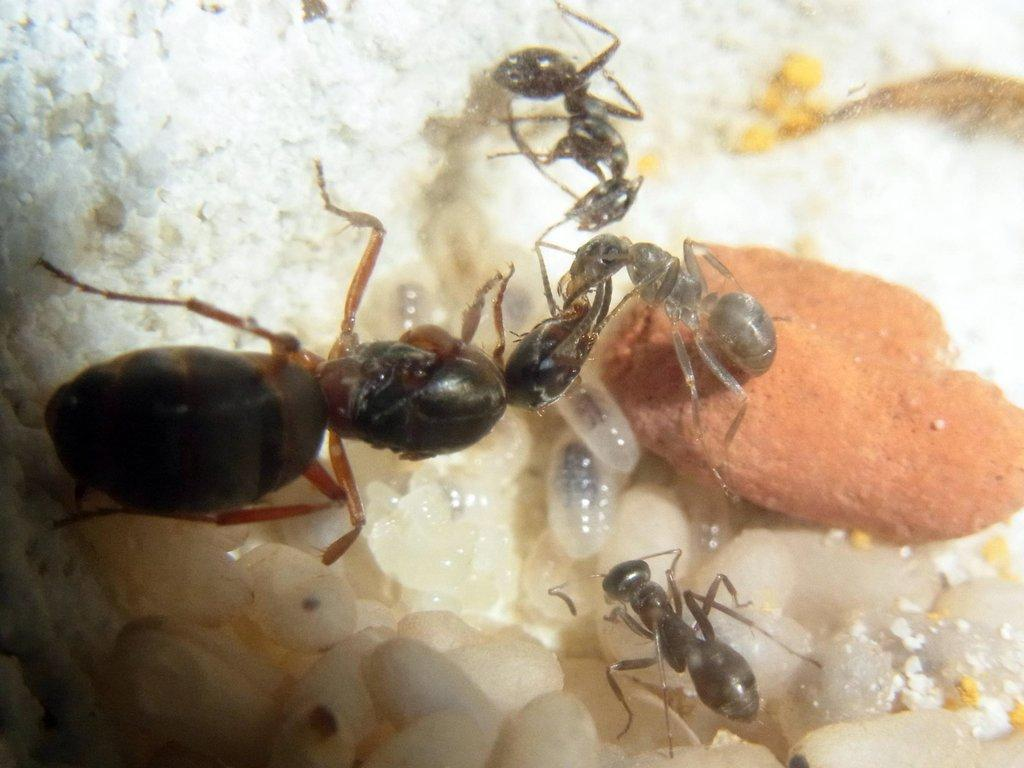What type of insects are present in the image? There are ants in the image. What are the ants doing in the image? The ants have eggs in the image. Where are the ants and their eggs located? The ants and their eggs are on some food in the image. What type of bird can be seen flying over the ants in the image? There is no bird present in the image; it only features ants and their eggs on some food. 